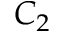<formula> <loc_0><loc_0><loc_500><loc_500>C _ { 2 }</formula> 